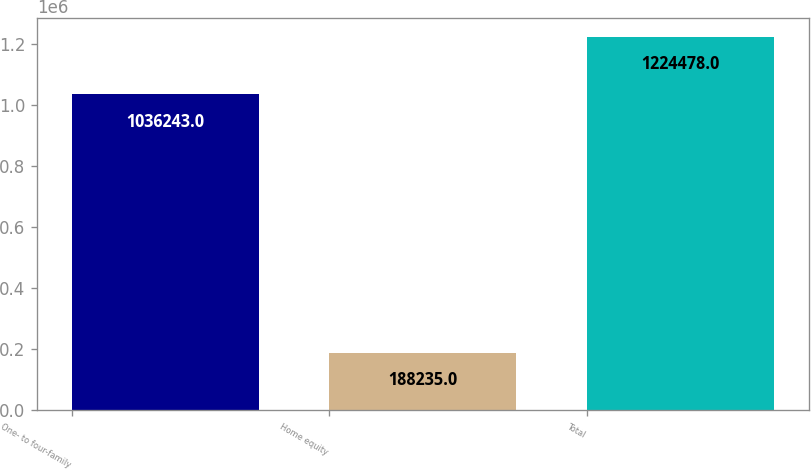Convert chart. <chart><loc_0><loc_0><loc_500><loc_500><bar_chart><fcel>One- to four-family<fcel>Home equity<fcel>Total<nl><fcel>1.03624e+06<fcel>188235<fcel>1.22448e+06<nl></chart> 